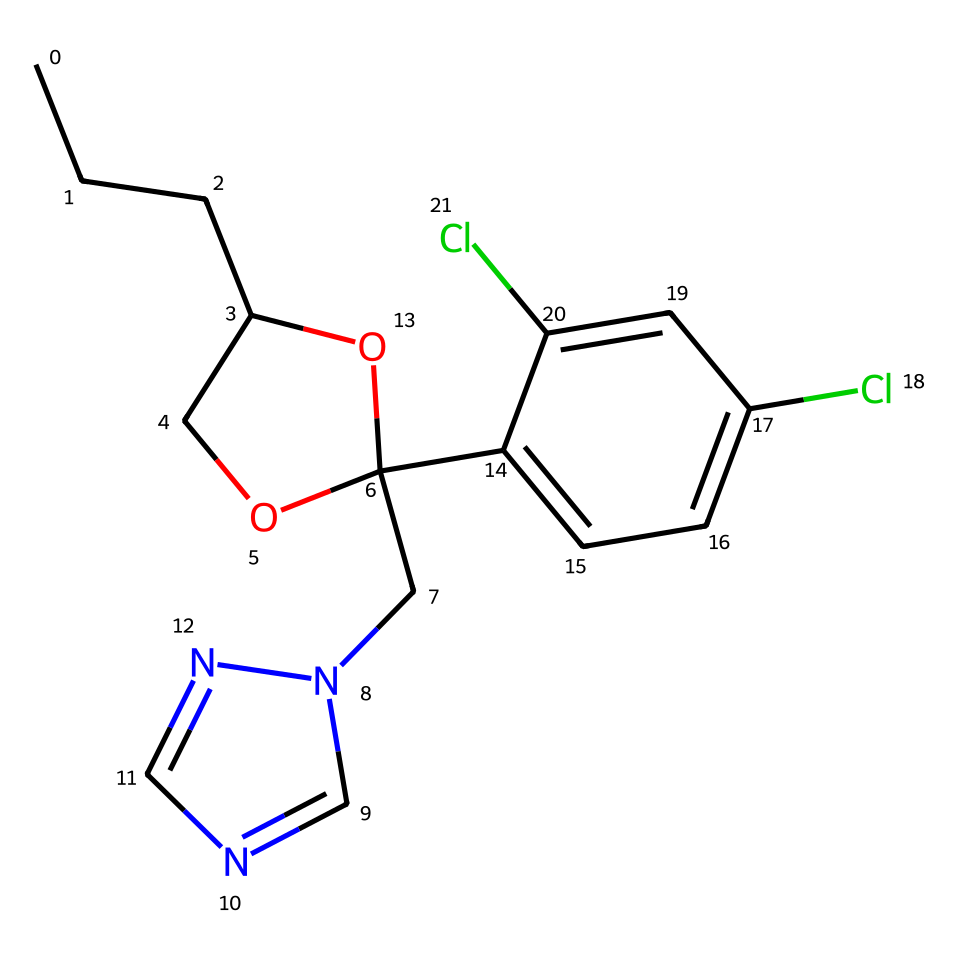What is the molecular formula of propiconazole? By analyzing the SMILES representation, we can identify the individual atoms present in the molecule. The SMILES indicates the presence of 14 carbon (C) atoms, 16 hydrogen (H) atoms, 2 chlorine (Cl) atoms, 3 nitrogen (N) atoms, and 1 oxygen (O) atom. Thus, the molecular formula can be derived as C14H16Cl2N3O.
Answer: C14H16Cl2N3O How many rings are present in the structure of propiconazole? The SMILES representation contains cyclic structures denoted by numbers (1 and 2). This indicates that there are two rings in the chemical structure, which can be visually confirmed by drawing the structure.
Answer: 2 What functional groups are present in propiconazole? The SMILES representation indicates the presence of a triazole ring and a phenolic hydroxyl group (as seen with the -OH). The triazole is identified by the nitrogen atoms in a 5-membered ring structure.
Answer: triazole and hydroxyl group What can be inferred about the polarity of propiconazole? Given the presence of both polar functional groups (like the hydroxyl group) and nonpolar carbon chains, the overall molecule is likely to be amphiphilic, meaning it has both polar and nonpolar characteristics, indicating potential solubility in both water and organic solvents.
Answer: amphiphilic Is propiconazole likely to be a systemic or contact fungicide? Due to its chemical structure, particularly the presence of the triazole moiety which allows it to be absorbed by plants effectively, propiconazole is classified as a systemic fungicide.
Answer: systemic 